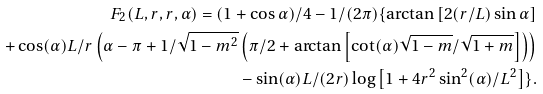<formula> <loc_0><loc_0><loc_500><loc_500>F _ { 2 } ( L , r , r , \alpha ) = ( 1 + \cos \alpha ) / 4 - 1 / ( 2 \pi ) \{ \arctan \left [ 2 ( r / L ) \sin \alpha \right ] \\ + \cos ( \alpha ) L / r \left ( \alpha - \pi + 1 / \sqrt { 1 - m ^ { 2 } } \left ( \pi / 2 + \arctan \left [ \cot ( \alpha ) \sqrt { 1 - m } / \sqrt { 1 + m } \right ] \right ) \right ) \\ - \sin ( \alpha ) L / ( 2 r ) \log \left [ 1 + 4 r ^ { 2 } \sin ^ { 2 } ( \alpha ) / L ^ { 2 } \right ] \} .</formula> 